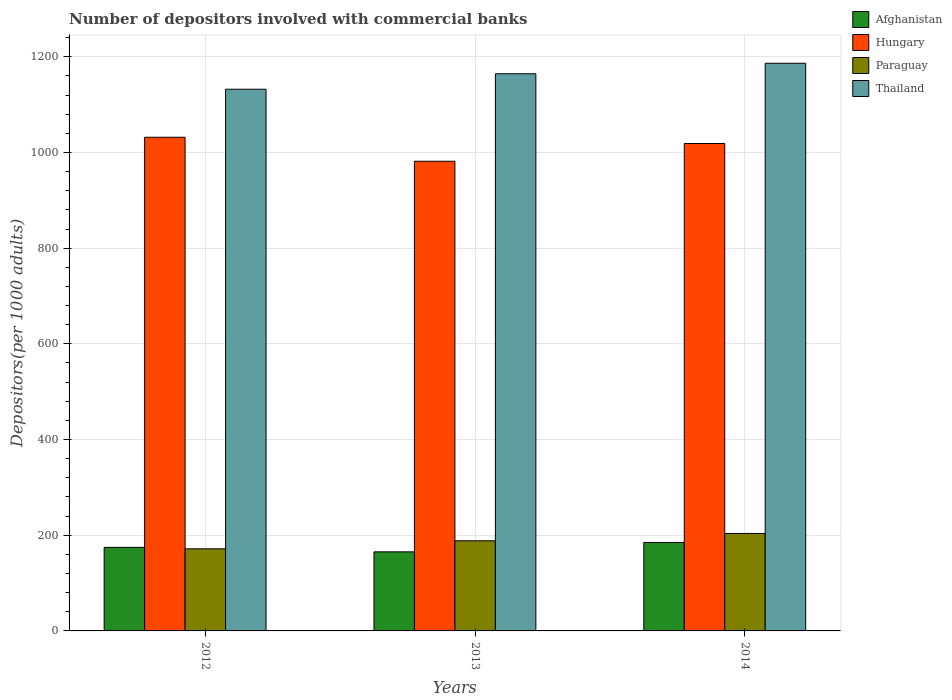How many groups of bars are there?
Your response must be concise. 3. How many bars are there on the 2nd tick from the right?
Your response must be concise. 4. What is the number of depositors involved with commercial banks in Hungary in 2012?
Your response must be concise. 1031.82. Across all years, what is the maximum number of depositors involved with commercial banks in Paraguay?
Provide a short and direct response. 203.69. Across all years, what is the minimum number of depositors involved with commercial banks in Afghanistan?
Keep it short and to the point. 165.27. What is the total number of depositors involved with commercial banks in Paraguay in the graph?
Provide a succinct answer. 563.72. What is the difference between the number of depositors involved with commercial banks in Paraguay in 2013 and that in 2014?
Your answer should be compact. -15.28. What is the difference between the number of depositors involved with commercial banks in Thailand in 2012 and the number of depositors involved with commercial banks in Afghanistan in 2013?
Offer a very short reply. 966.93. What is the average number of depositors involved with commercial banks in Hungary per year?
Offer a very short reply. 1010.74. In the year 2012, what is the difference between the number of depositors involved with commercial banks in Thailand and number of depositors involved with commercial banks in Hungary?
Keep it short and to the point. 100.39. In how many years, is the number of depositors involved with commercial banks in Hungary greater than 400?
Give a very brief answer. 3. What is the ratio of the number of depositors involved with commercial banks in Afghanistan in 2013 to that in 2014?
Keep it short and to the point. 0.89. Is the difference between the number of depositors involved with commercial banks in Thailand in 2012 and 2013 greater than the difference between the number of depositors involved with commercial banks in Hungary in 2012 and 2013?
Your answer should be very brief. No. What is the difference between the highest and the second highest number of depositors involved with commercial banks in Hungary?
Your answer should be very brief. 13.07. What is the difference between the highest and the lowest number of depositors involved with commercial banks in Hungary?
Make the answer very short. 50.15. In how many years, is the number of depositors involved with commercial banks in Hungary greater than the average number of depositors involved with commercial banks in Hungary taken over all years?
Offer a very short reply. 2. What does the 4th bar from the left in 2014 represents?
Offer a terse response. Thailand. What does the 2nd bar from the right in 2013 represents?
Give a very brief answer. Paraguay. Is it the case that in every year, the sum of the number of depositors involved with commercial banks in Thailand and number of depositors involved with commercial banks in Hungary is greater than the number of depositors involved with commercial banks in Afghanistan?
Provide a short and direct response. Yes. How many bars are there?
Make the answer very short. 12. Are all the bars in the graph horizontal?
Offer a terse response. No. What is the difference between two consecutive major ticks on the Y-axis?
Keep it short and to the point. 200. Does the graph contain grids?
Offer a terse response. Yes. Where does the legend appear in the graph?
Provide a short and direct response. Top right. How many legend labels are there?
Provide a short and direct response. 4. How are the legend labels stacked?
Your answer should be compact. Vertical. What is the title of the graph?
Offer a terse response. Number of depositors involved with commercial banks. What is the label or title of the Y-axis?
Give a very brief answer. Depositors(per 1000 adults). What is the Depositors(per 1000 adults) in Afghanistan in 2012?
Your answer should be compact. 174.63. What is the Depositors(per 1000 adults) in Hungary in 2012?
Provide a succinct answer. 1031.82. What is the Depositors(per 1000 adults) in Paraguay in 2012?
Your answer should be compact. 171.62. What is the Depositors(per 1000 adults) of Thailand in 2012?
Make the answer very short. 1132.21. What is the Depositors(per 1000 adults) of Afghanistan in 2013?
Make the answer very short. 165.27. What is the Depositors(per 1000 adults) of Hungary in 2013?
Ensure brevity in your answer.  981.67. What is the Depositors(per 1000 adults) in Paraguay in 2013?
Offer a very short reply. 188.41. What is the Depositors(per 1000 adults) of Thailand in 2013?
Provide a succinct answer. 1164.56. What is the Depositors(per 1000 adults) of Afghanistan in 2014?
Offer a terse response. 184.88. What is the Depositors(per 1000 adults) in Hungary in 2014?
Offer a terse response. 1018.74. What is the Depositors(per 1000 adults) of Paraguay in 2014?
Give a very brief answer. 203.69. What is the Depositors(per 1000 adults) in Thailand in 2014?
Ensure brevity in your answer.  1186.49. Across all years, what is the maximum Depositors(per 1000 adults) in Afghanistan?
Give a very brief answer. 184.88. Across all years, what is the maximum Depositors(per 1000 adults) of Hungary?
Give a very brief answer. 1031.82. Across all years, what is the maximum Depositors(per 1000 adults) in Paraguay?
Your answer should be very brief. 203.69. Across all years, what is the maximum Depositors(per 1000 adults) of Thailand?
Your answer should be very brief. 1186.49. Across all years, what is the minimum Depositors(per 1000 adults) of Afghanistan?
Keep it short and to the point. 165.27. Across all years, what is the minimum Depositors(per 1000 adults) in Hungary?
Offer a very short reply. 981.67. Across all years, what is the minimum Depositors(per 1000 adults) in Paraguay?
Give a very brief answer. 171.62. Across all years, what is the minimum Depositors(per 1000 adults) in Thailand?
Provide a succinct answer. 1132.21. What is the total Depositors(per 1000 adults) in Afghanistan in the graph?
Give a very brief answer. 524.78. What is the total Depositors(per 1000 adults) in Hungary in the graph?
Your answer should be very brief. 3032.23. What is the total Depositors(per 1000 adults) in Paraguay in the graph?
Make the answer very short. 563.72. What is the total Depositors(per 1000 adults) in Thailand in the graph?
Your response must be concise. 3483.25. What is the difference between the Depositors(per 1000 adults) in Afghanistan in 2012 and that in 2013?
Your answer should be compact. 9.36. What is the difference between the Depositors(per 1000 adults) in Hungary in 2012 and that in 2013?
Offer a very short reply. 50.15. What is the difference between the Depositors(per 1000 adults) of Paraguay in 2012 and that in 2013?
Your answer should be compact. -16.8. What is the difference between the Depositors(per 1000 adults) of Thailand in 2012 and that in 2013?
Provide a short and direct response. -32.35. What is the difference between the Depositors(per 1000 adults) of Afghanistan in 2012 and that in 2014?
Provide a short and direct response. -10.24. What is the difference between the Depositors(per 1000 adults) in Hungary in 2012 and that in 2014?
Your response must be concise. 13.07. What is the difference between the Depositors(per 1000 adults) in Paraguay in 2012 and that in 2014?
Your answer should be very brief. -32.08. What is the difference between the Depositors(per 1000 adults) of Thailand in 2012 and that in 2014?
Make the answer very short. -54.28. What is the difference between the Depositors(per 1000 adults) in Afghanistan in 2013 and that in 2014?
Give a very brief answer. -19.61. What is the difference between the Depositors(per 1000 adults) in Hungary in 2013 and that in 2014?
Give a very brief answer. -37.07. What is the difference between the Depositors(per 1000 adults) in Paraguay in 2013 and that in 2014?
Offer a terse response. -15.28. What is the difference between the Depositors(per 1000 adults) in Thailand in 2013 and that in 2014?
Your answer should be very brief. -21.93. What is the difference between the Depositors(per 1000 adults) of Afghanistan in 2012 and the Depositors(per 1000 adults) of Hungary in 2013?
Make the answer very short. -807.03. What is the difference between the Depositors(per 1000 adults) in Afghanistan in 2012 and the Depositors(per 1000 adults) in Paraguay in 2013?
Give a very brief answer. -13.78. What is the difference between the Depositors(per 1000 adults) of Afghanistan in 2012 and the Depositors(per 1000 adults) of Thailand in 2013?
Your response must be concise. -989.92. What is the difference between the Depositors(per 1000 adults) in Hungary in 2012 and the Depositors(per 1000 adults) in Paraguay in 2013?
Make the answer very short. 843.4. What is the difference between the Depositors(per 1000 adults) in Hungary in 2012 and the Depositors(per 1000 adults) in Thailand in 2013?
Offer a terse response. -132.74. What is the difference between the Depositors(per 1000 adults) in Paraguay in 2012 and the Depositors(per 1000 adults) in Thailand in 2013?
Give a very brief answer. -992.94. What is the difference between the Depositors(per 1000 adults) of Afghanistan in 2012 and the Depositors(per 1000 adults) of Hungary in 2014?
Offer a terse response. -844.11. What is the difference between the Depositors(per 1000 adults) of Afghanistan in 2012 and the Depositors(per 1000 adults) of Paraguay in 2014?
Keep it short and to the point. -29.06. What is the difference between the Depositors(per 1000 adults) in Afghanistan in 2012 and the Depositors(per 1000 adults) in Thailand in 2014?
Your response must be concise. -1011.86. What is the difference between the Depositors(per 1000 adults) in Hungary in 2012 and the Depositors(per 1000 adults) in Paraguay in 2014?
Provide a succinct answer. 828.12. What is the difference between the Depositors(per 1000 adults) in Hungary in 2012 and the Depositors(per 1000 adults) in Thailand in 2014?
Your answer should be compact. -154.67. What is the difference between the Depositors(per 1000 adults) in Paraguay in 2012 and the Depositors(per 1000 adults) in Thailand in 2014?
Give a very brief answer. -1014.87. What is the difference between the Depositors(per 1000 adults) in Afghanistan in 2013 and the Depositors(per 1000 adults) in Hungary in 2014?
Provide a succinct answer. -853.47. What is the difference between the Depositors(per 1000 adults) of Afghanistan in 2013 and the Depositors(per 1000 adults) of Paraguay in 2014?
Provide a succinct answer. -38.42. What is the difference between the Depositors(per 1000 adults) in Afghanistan in 2013 and the Depositors(per 1000 adults) in Thailand in 2014?
Offer a very short reply. -1021.22. What is the difference between the Depositors(per 1000 adults) of Hungary in 2013 and the Depositors(per 1000 adults) of Paraguay in 2014?
Offer a very short reply. 777.98. What is the difference between the Depositors(per 1000 adults) in Hungary in 2013 and the Depositors(per 1000 adults) in Thailand in 2014?
Your answer should be very brief. -204.82. What is the difference between the Depositors(per 1000 adults) in Paraguay in 2013 and the Depositors(per 1000 adults) in Thailand in 2014?
Offer a very short reply. -998.08. What is the average Depositors(per 1000 adults) in Afghanistan per year?
Provide a succinct answer. 174.93. What is the average Depositors(per 1000 adults) in Hungary per year?
Make the answer very short. 1010.74. What is the average Depositors(per 1000 adults) in Paraguay per year?
Your answer should be compact. 187.91. What is the average Depositors(per 1000 adults) of Thailand per year?
Keep it short and to the point. 1161.08. In the year 2012, what is the difference between the Depositors(per 1000 adults) in Afghanistan and Depositors(per 1000 adults) in Hungary?
Ensure brevity in your answer.  -857.18. In the year 2012, what is the difference between the Depositors(per 1000 adults) of Afghanistan and Depositors(per 1000 adults) of Paraguay?
Provide a succinct answer. 3.02. In the year 2012, what is the difference between the Depositors(per 1000 adults) of Afghanistan and Depositors(per 1000 adults) of Thailand?
Your response must be concise. -957.57. In the year 2012, what is the difference between the Depositors(per 1000 adults) of Hungary and Depositors(per 1000 adults) of Paraguay?
Your answer should be compact. 860.2. In the year 2012, what is the difference between the Depositors(per 1000 adults) in Hungary and Depositors(per 1000 adults) in Thailand?
Offer a terse response. -100.39. In the year 2012, what is the difference between the Depositors(per 1000 adults) of Paraguay and Depositors(per 1000 adults) of Thailand?
Ensure brevity in your answer.  -960.59. In the year 2013, what is the difference between the Depositors(per 1000 adults) of Afghanistan and Depositors(per 1000 adults) of Hungary?
Your answer should be compact. -816.4. In the year 2013, what is the difference between the Depositors(per 1000 adults) in Afghanistan and Depositors(per 1000 adults) in Paraguay?
Your answer should be compact. -23.14. In the year 2013, what is the difference between the Depositors(per 1000 adults) of Afghanistan and Depositors(per 1000 adults) of Thailand?
Make the answer very short. -999.29. In the year 2013, what is the difference between the Depositors(per 1000 adults) of Hungary and Depositors(per 1000 adults) of Paraguay?
Offer a terse response. 793.25. In the year 2013, what is the difference between the Depositors(per 1000 adults) in Hungary and Depositors(per 1000 adults) in Thailand?
Ensure brevity in your answer.  -182.89. In the year 2013, what is the difference between the Depositors(per 1000 adults) of Paraguay and Depositors(per 1000 adults) of Thailand?
Offer a very short reply. -976.14. In the year 2014, what is the difference between the Depositors(per 1000 adults) in Afghanistan and Depositors(per 1000 adults) in Hungary?
Keep it short and to the point. -833.87. In the year 2014, what is the difference between the Depositors(per 1000 adults) of Afghanistan and Depositors(per 1000 adults) of Paraguay?
Offer a very short reply. -18.81. In the year 2014, what is the difference between the Depositors(per 1000 adults) of Afghanistan and Depositors(per 1000 adults) of Thailand?
Make the answer very short. -1001.61. In the year 2014, what is the difference between the Depositors(per 1000 adults) in Hungary and Depositors(per 1000 adults) in Paraguay?
Keep it short and to the point. 815.05. In the year 2014, what is the difference between the Depositors(per 1000 adults) of Hungary and Depositors(per 1000 adults) of Thailand?
Your answer should be compact. -167.75. In the year 2014, what is the difference between the Depositors(per 1000 adults) in Paraguay and Depositors(per 1000 adults) in Thailand?
Make the answer very short. -982.8. What is the ratio of the Depositors(per 1000 adults) in Afghanistan in 2012 to that in 2013?
Offer a terse response. 1.06. What is the ratio of the Depositors(per 1000 adults) of Hungary in 2012 to that in 2013?
Make the answer very short. 1.05. What is the ratio of the Depositors(per 1000 adults) in Paraguay in 2012 to that in 2013?
Provide a short and direct response. 0.91. What is the ratio of the Depositors(per 1000 adults) of Thailand in 2012 to that in 2013?
Keep it short and to the point. 0.97. What is the ratio of the Depositors(per 1000 adults) of Afghanistan in 2012 to that in 2014?
Make the answer very short. 0.94. What is the ratio of the Depositors(per 1000 adults) of Hungary in 2012 to that in 2014?
Provide a short and direct response. 1.01. What is the ratio of the Depositors(per 1000 adults) in Paraguay in 2012 to that in 2014?
Your answer should be compact. 0.84. What is the ratio of the Depositors(per 1000 adults) of Thailand in 2012 to that in 2014?
Your answer should be very brief. 0.95. What is the ratio of the Depositors(per 1000 adults) of Afghanistan in 2013 to that in 2014?
Your answer should be very brief. 0.89. What is the ratio of the Depositors(per 1000 adults) in Hungary in 2013 to that in 2014?
Give a very brief answer. 0.96. What is the ratio of the Depositors(per 1000 adults) in Paraguay in 2013 to that in 2014?
Your response must be concise. 0.93. What is the ratio of the Depositors(per 1000 adults) in Thailand in 2013 to that in 2014?
Your answer should be compact. 0.98. What is the difference between the highest and the second highest Depositors(per 1000 adults) of Afghanistan?
Ensure brevity in your answer.  10.24. What is the difference between the highest and the second highest Depositors(per 1000 adults) in Hungary?
Your response must be concise. 13.07. What is the difference between the highest and the second highest Depositors(per 1000 adults) in Paraguay?
Offer a very short reply. 15.28. What is the difference between the highest and the second highest Depositors(per 1000 adults) in Thailand?
Keep it short and to the point. 21.93. What is the difference between the highest and the lowest Depositors(per 1000 adults) of Afghanistan?
Provide a short and direct response. 19.61. What is the difference between the highest and the lowest Depositors(per 1000 adults) of Hungary?
Offer a very short reply. 50.15. What is the difference between the highest and the lowest Depositors(per 1000 adults) of Paraguay?
Give a very brief answer. 32.08. What is the difference between the highest and the lowest Depositors(per 1000 adults) of Thailand?
Offer a terse response. 54.28. 